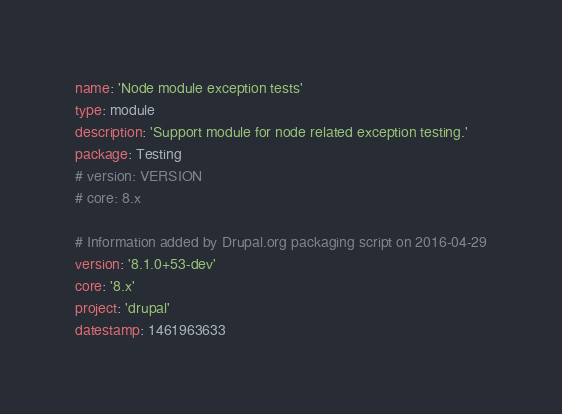<code> <loc_0><loc_0><loc_500><loc_500><_YAML_>name: 'Node module exception tests'
type: module
description: 'Support module for node related exception testing.'
package: Testing
# version: VERSION
# core: 8.x

# Information added by Drupal.org packaging script on 2016-04-29
version: '8.1.0+53-dev'
core: '8.x'
project: 'drupal'
datestamp: 1461963633
</code> 